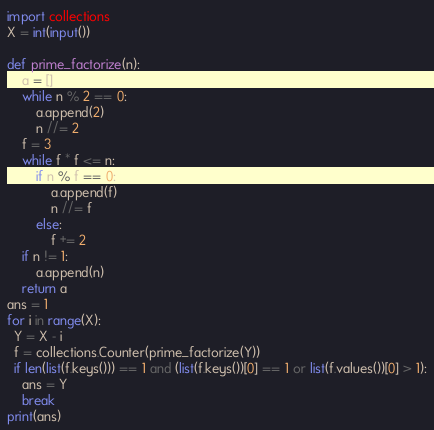<code> <loc_0><loc_0><loc_500><loc_500><_Python_>import collections
X = int(input())

def prime_factorize(n):
    a = []
    while n % 2 == 0:
        a.append(2)
        n //= 2
    f = 3
    while f * f <= n:
        if n % f == 0:
            a.append(f)
            n //= f
        else:
            f += 2
    if n != 1:
        a.append(n)
    return a
ans = 1
for i in range(X):
  Y = X - i
  f = collections.Counter(prime_factorize(Y))
  if len(list(f.keys())) == 1 and (list(f.keys())[0] == 1 or list(f.values())[0] > 1):
    ans = Y
    break
print(ans)</code> 